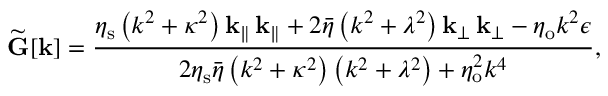Convert formula to latex. <formula><loc_0><loc_0><loc_500><loc_500>\widetilde { G } [ k ] = \frac { \eta _ { s } \left ( k ^ { 2 } + \kappa ^ { 2 } \right ) k _ { \| } \, k _ { \| } + 2 \bar { \eta } \left ( k ^ { 2 } + \lambda ^ { 2 } \right ) k _ { \perp } \, k _ { \perp } - \eta _ { o } k ^ { 2 } \epsilon } { 2 \eta _ { s } \bar { \eta } \left ( k ^ { 2 } + \kappa ^ { 2 } \right ) \left ( k ^ { 2 } + \lambda ^ { 2 } \right ) + \eta _ { o } ^ { 2 } k ^ { 4 } } ,</formula> 